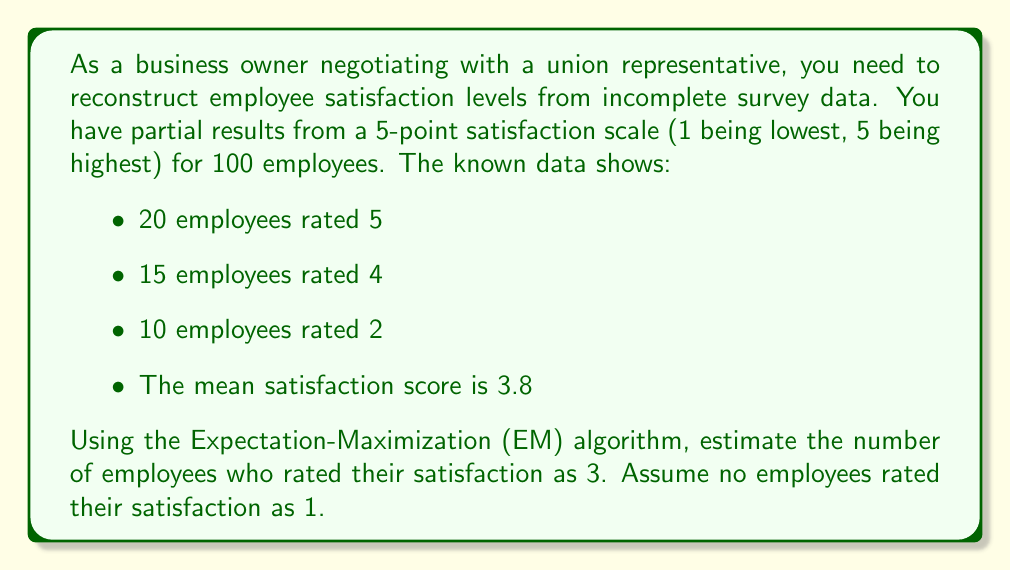Could you help me with this problem? Let's approach this step-by-step using the EM algorithm:

1) First, let's identify what we know:
   - Total employees: $N = 100$
   - $n_5 = 20$, $n_4 = 15$, $n_2 = 10$
   - Mean satisfaction: $\mu = 3.8$
   - $n_1 = 0$ (given)

2) Let $n_3$ be the unknown number of employees who rated 3. We can express $n_3$ in terms of $n_1$:
   $n_3 = 100 - (20 + 15 + 10 + n_1) = 55 - n_1$

3) We can set up an equation using the mean:
   $\frac{5n_5 + 4n_4 + 3n_3 + 2n_2 + 1n_1}{N} = \mu$

4) Substituting known values:
   $\frac{5(20) + 4(15) + 3(55-n_1) + 2(10) + 1(n_1)}{100} = 3.8$

5) Simplify:
   $\frac{100 + 60 + 165 - 3n_1 + 20 + n_1}{100} = 3.8$

6) Solve for $n_1$:
   $345 - 2n_1 = 380$
   $-2n_1 = 35$
   $n_1 = -17.5$

7) Since $n_1$ cannot be negative, we assume $n_1 = 0$ (which aligns with our initial assumption).

8) Therefore, $n_3 = 55 - n_1 = 55 - 0 = 55$

Thus, we estimate that 55 employees rated their satisfaction as 3.
Answer: 55 employees 